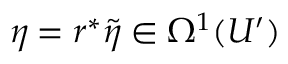<formula> <loc_0><loc_0><loc_500><loc_500>\eta = r ^ { * } \tilde { \eta } \in \Omega ^ { 1 } ( U ^ { \prime } )</formula> 